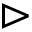<formula> <loc_0><loc_0><loc_500><loc_500>\vartriangleright</formula> 